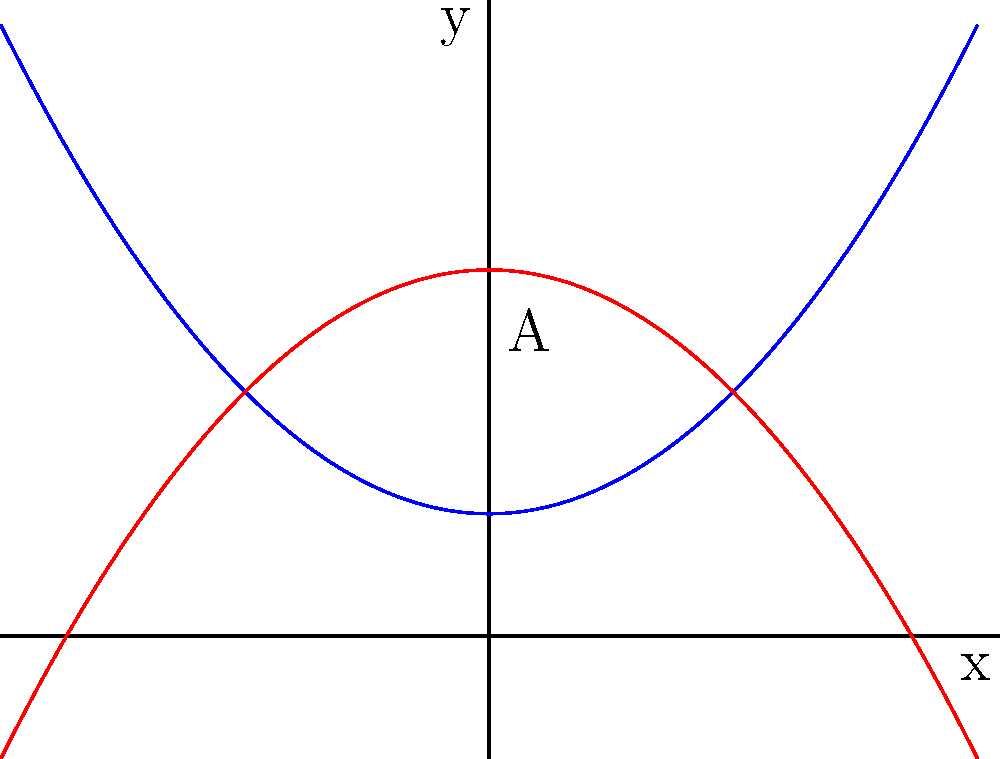As a parent who values education, you're interested in understanding how school district funding is calculated based on various factors. The graph above represents two polynomial functions that model different aspects of school funding. The blue curve represents the base funding per student ($f(x) = 0.25x^2 + 1$), and the red curve represents additional funding based on special programs ($g(x) = -0.25x^2 + 3$), where $x$ represents the number of years a policy has been in place (centered at 0).

The area between these two curves (labeled A) represents the total additional funding available for special educational programs. Calculate the area of region A. To find the area between the two curves, we need to:

1) Find the points of intersection of the two curves
2) Set up an integral to calculate the area
3) Solve the integral

Step 1: Find points of intersection
$f(x) = g(x)$
$0.25x^2 + 1 = -0.25x^2 + 3$
$0.5x^2 = 2$
$x^2 = 4$
$x = \pm 2$

The curves intersect at $x = -2$ and $x = 2$.

Step 2: Set up the integral
Area = $\int_{-2}^{2} [g(x) - f(x)] dx$
     = $\int_{-2}^{2} [(-0.25x^2 + 3) - (0.25x^2 + 1)] dx$
     = $\int_{-2}^{2} [-0.5x^2 + 2] dx$

Step 3: Solve the integral
$= [-\frac{1}{6}x^3 + 2x]_{-2}^{2}$
$= [(-\frac{8}{6} + 4) - (-\frac{-8}{6} - 4)]$
$= [\frac{16}{6} - (-\frac{16}{6})]$
$= \frac{32}{6}$
$= \frac{16}{3}$

Therefore, the area of region A is $\frac{16}{3}$ square units.
Answer: $\frac{16}{3}$ square units 